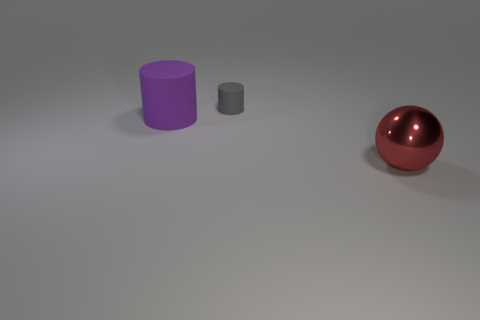What is the big red thing made of?
Your answer should be compact. Metal. There is a purple thing that is the same size as the shiny ball; what is its shape?
Ensure brevity in your answer.  Cylinder. Is there another tiny thing of the same color as the small object?
Your response must be concise. No. There is a sphere; is it the same color as the rubber cylinder that is to the left of the gray rubber cylinder?
Offer a terse response. No. The large metal ball that is in front of the big object that is left of the red sphere is what color?
Your answer should be compact. Red. Are there any big objects left of the cylinder to the right of the large object behind the red metallic ball?
Ensure brevity in your answer.  Yes. The cylinder that is the same material as the tiny gray thing is what color?
Offer a terse response. Purple. What number of big gray objects have the same material as the small cylinder?
Ensure brevity in your answer.  0. Is the purple thing made of the same material as the object in front of the big purple cylinder?
Make the answer very short. No. How many objects are either cylinders to the left of the tiny matte thing or gray matte objects?
Offer a terse response. 2. 